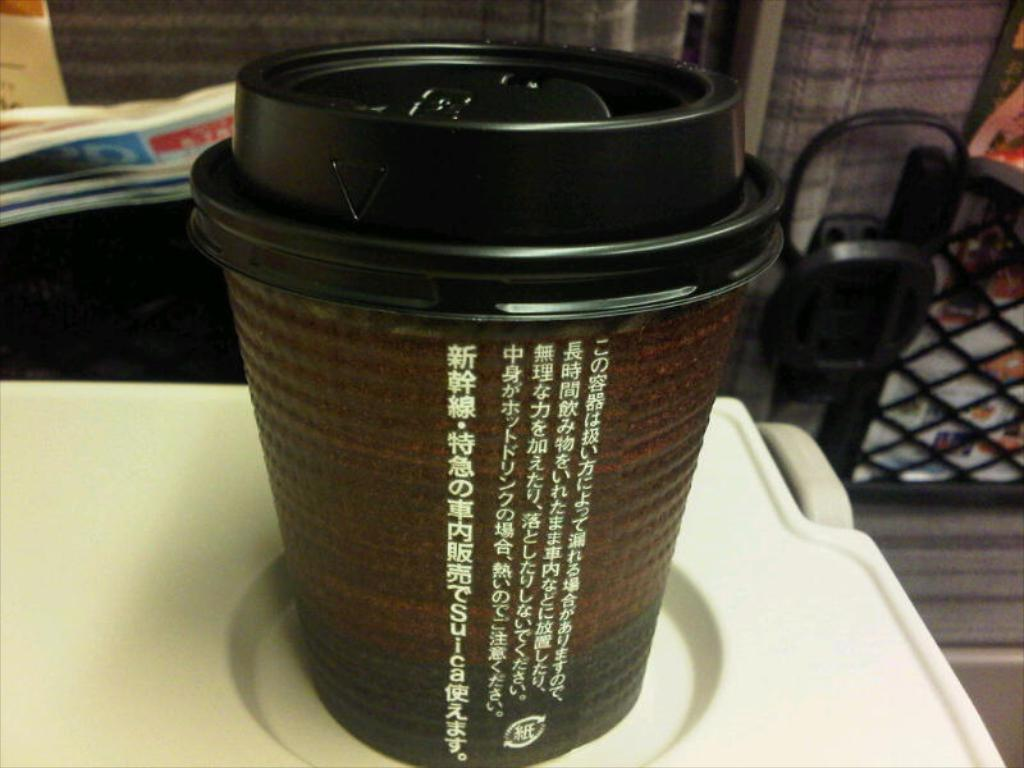What object is located in the center of the image? There is a cup in the middle of the image. Where is the paper positioned in the image? The paper is on the left side of the image. How many leaves can be seen on the toad in the image? There is no toad or leaves present in the image. 